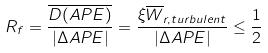<formula> <loc_0><loc_0><loc_500><loc_500>R _ { f } = \frac { \overline { D ( A P E ) } } { | \Delta A P E | } = \frac { \xi \overline { W } _ { r , t u r b u l e n t } } { | \Delta A P E | } \leq \frac { 1 } { 2 }</formula> 